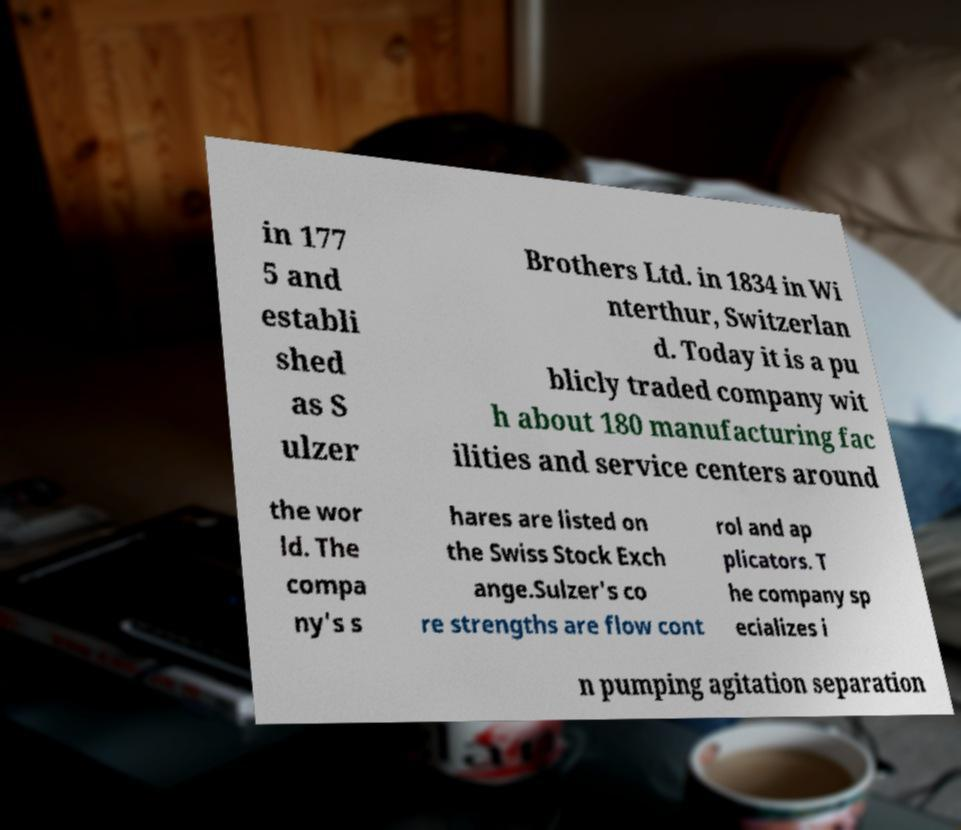What messages or text are displayed in this image? I need them in a readable, typed format. in 177 5 and establi shed as S ulzer Brothers Ltd. in 1834 in Wi nterthur, Switzerlan d. Today it is a pu blicly traded company wit h about 180 manufacturing fac ilities and service centers around the wor ld. The compa ny's s hares are listed on the Swiss Stock Exch ange.Sulzer's co re strengths are flow cont rol and ap plicators. T he company sp ecializes i n pumping agitation separation 